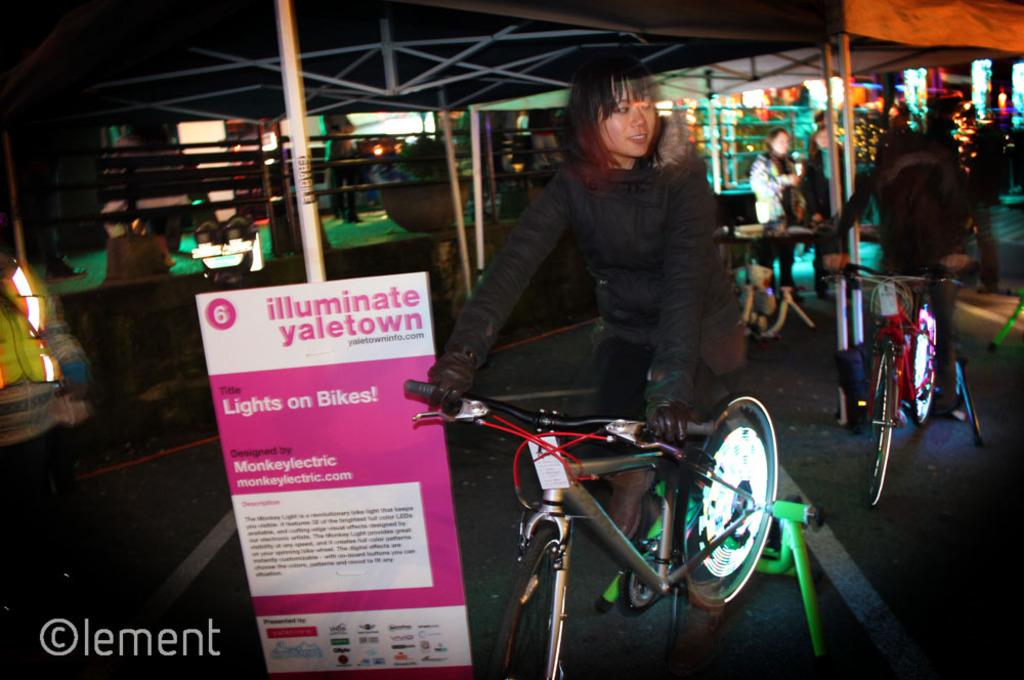How many people are in the image? There are two women in the image. What are the women doing in the image? The women are riding bicycles. Are the bicycles being used for transportation or are they stationary? The bicycles are on a stand, so they are stationary in the image. What type of class are the women attending in the image? There is no class or educational setting depicted in the image; the women are simply riding bicycles on a stand. How many crows can be seen flying in the background of the image? There are no crows present in the image; it features two women riding bicycles on a stand. 